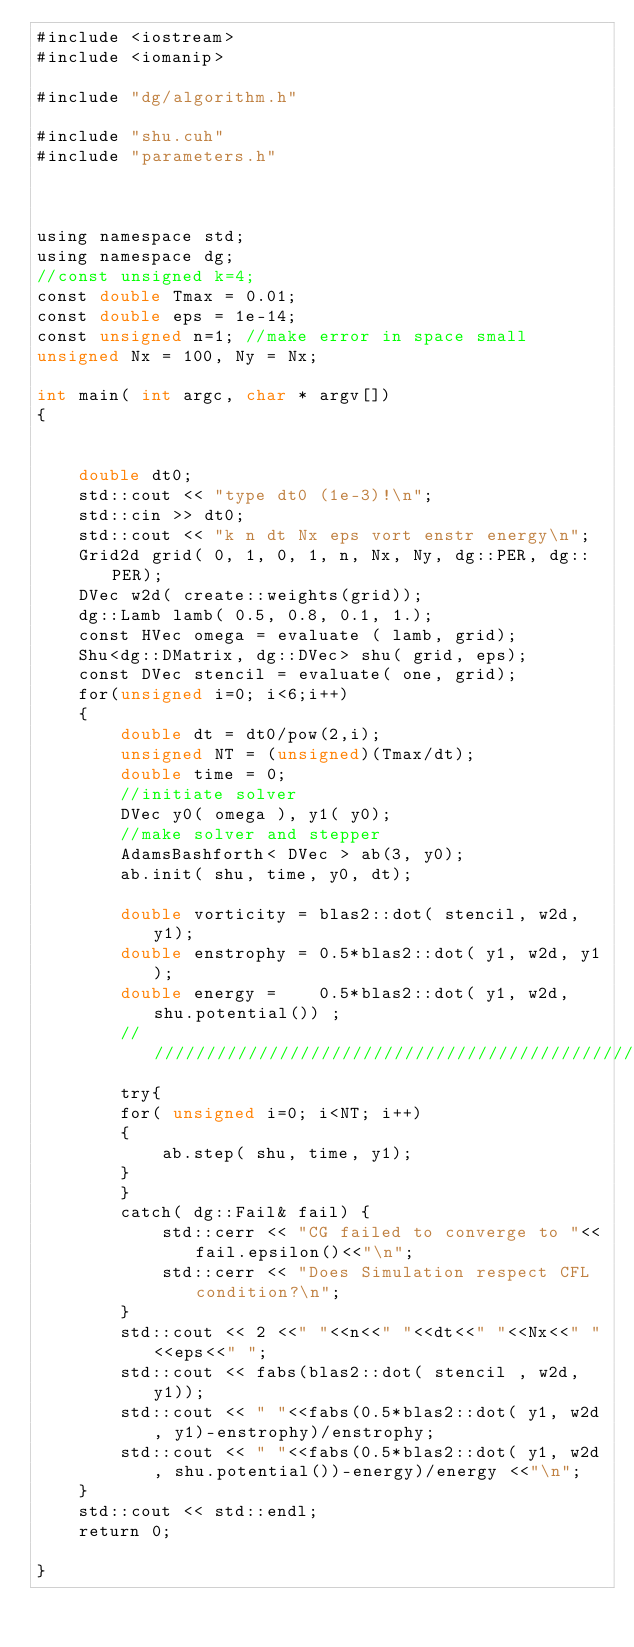<code> <loc_0><loc_0><loc_500><loc_500><_Cuda_>#include <iostream>
#include <iomanip>

#include "dg/algorithm.h"

#include "shu.cuh"
#include "parameters.h"



using namespace std;
using namespace dg;
//const unsigned k=4;
const double Tmax = 0.01;
const double eps = 1e-14;
const unsigned n=1; //make error in space small
unsigned Nx = 100, Ny = Nx;

int main( int argc, char * argv[])
{


    double dt0; 
    std::cout << "type dt0 (1e-3)!\n";
    std::cin >> dt0;
    std::cout << "k n dt Nx eps vort enstr energy\n";
    Grid2d grid( 0, 1, 0, 1, n, Nx, Ny, dg::PER, dg::PER);
    DVec w2d( create::weights(grid));
    dg::Lamb lamb( 0.5, 0.8, 0.1, 1.);
    const HVec omega = evaluate ( lamb, grid);
    Shu<dg::DMatrix, dg::DVec> shu( grid, eps);
    const DVec stencil = evaluate( one, grid);
    for(unsigned i=0; i<6;i++)
    {
        double dt = dt0/pow(2,i);
        unsigned NT = (unsigned)(Tmax/dt);
        double time = 0;
        //initiate solver 
        DVec y0( omega ), y1( y0);
        //make solver and stepper
        AdamsBashforth< DVec > ab(3, y0);
        ab.init( shu, time, y0, dt);

        double vorticity = blas2::dot( stencil, w2d, y1);
        double enstrophy = 0.5*blas2::dot( y1, w2d, y1);
        double energy =    0.5*blas2::dot( y1, w2d, shu.potential()) ;
        /////////////////////////////////////////////////////////////////
        try{
        for( unsigned i=0; i<NT; i++)
        {
            ab.step( shu, time, y1);
        }
        }
        catch( dg::Fail& fail) { 
            std::cerr << "CG failed to converge to "<<fail.epsilon()<<"\n";
            std::cerr << "Does Simulation respect CFL condition?\n";
        }
        std::cout << 2 <<" "<<n<<" "<<dt<<" "<<Nx<<" "<<eps<<" ";
        std::cout << fabs(blas2::dot( stencil , w2d, y1));
        std::cout << " "<<fabs(0.5*blas2::dot( y1, w2d, y1)-enstrophy)/enstrophy;
        std::cout << " "<<fabs(0.5*blas2::dot( y1, w2d, shu.potential())-energy)/energy <<"\n";
    }
    std::cout << std::endl;
    return 0;

}
</code> 